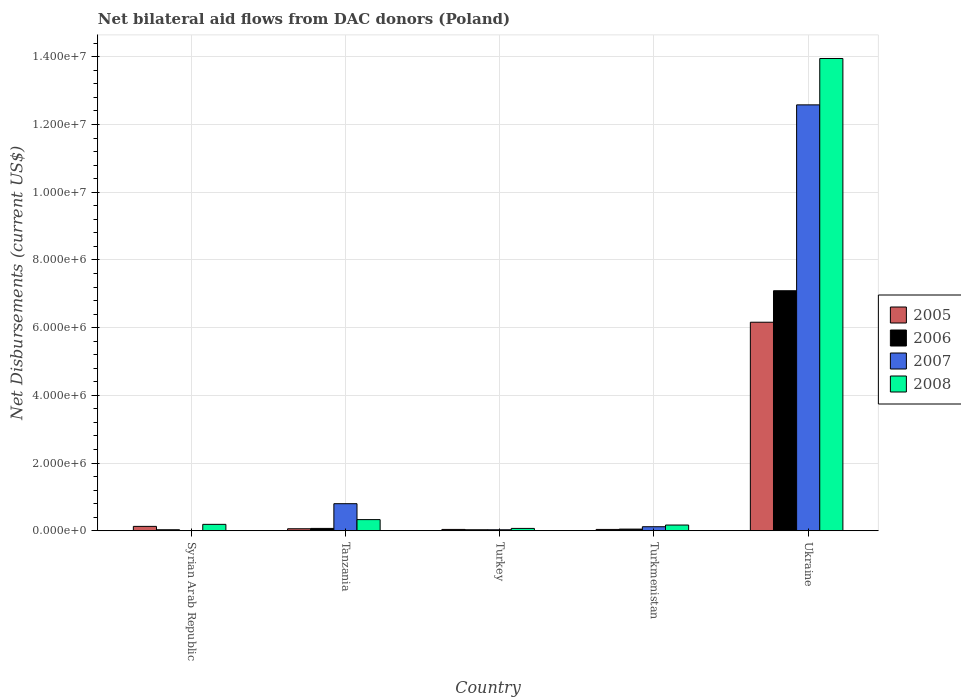How many bars are there on the 2nd tick from the left?
Provide a short and direct response. 4. What is the label of the 2nd group of bars from the left?
Your response must be concise. Tanzania. In how many cases, is the number of bars for a given country not equal to the number of legend labels?
Offer a very short reply. 1. What is the net bilateral aid flows in 2007 in Turkey?
Your response must be concise. 3.00e+04. Across all countries, what is the maximum net bilateral aid flows in 2007?
Provide a succinct answer. 1.26e+07. Across all countries, what is the minimum net bilateral aid flows in 2008?
Offer a very short reply. 7.00e+04. In which country was the net bilateral aid flows in 2006 maximum?
Offer a terse response. Ukraine. What is the total net bilateral aid flows in 2005 in the graph?
Offer a very short reply. 6.43e+06. What is the difference between the net bilateral aid flows in 2007 in Tanzania and the net bilateral aid flows in 2008 in Turkey?
Provide a succinct answer. 7.30e+05. What is the average net bilateral aid flows in 2008 per country?
Your answer should be very brief. 2.94e+06. What is the ratio of the net bilateral aid flows in 2006 in Syrian Arab Republic to that in Turkmenistan?
Your answer should be compact. 0.6. What is the difference between the highest and the second highest net bilateral aid flows in 2008?
Your response must be concise. 1.36e+07. What is the difference between the highest and the lowest net bilateral aid flows in 2005?
Provide a short and direct response. 6.12e+06. How many countries are there in the graph?
Offer a terse response. 5. Are the values on the major ticks of Y-axis written in scientific E-notation?
Your answer should be very brief. Yes. Does the graph contain grids?
Your answer should be compact. Yes. What is the title of the graph?
Keep it short and to the point. Net bilateral aid flows from DAC donors (Poland). Does "2005" appear as one of the legend labels in the graph?
Your answer should be very brief. Yes. What is the label or title of the Y-axis?
Offer a very short reply. Net Disbursements (current US$). What is the Net Disbursements (current US$) of 2005 in Syrian Arab Republic?
Ensure brevity in your answer.  1.30e+05. What is the Net Disbursements (current US$) of 2006 in Syrian Arab Republic?
Offer a terse response. 3.00e+04. What is the Net Disbursements (current US$) in 2007 in Syrian Arab Republic?
Your answer should be compact. 0. What is the Net Disbursements (current US$) of 2008 in Syrian Arab Republic?
Ensure brevity in your answer.  1.90e+05. What is the Net Disbursements (current US$) of 2005 in Tanzania?
Your answer should be compact. 6.00e+04. What is the Net Disbursements (current US$) of 2006 in Tanzania?
Give a very brief answer. 7.00e+04. What is the Net Disbursements (current US$) in 2007 in Tanzania?
Your answer should be very brief. 8.00e+05. What is the Net Disbursements (current US$) of 2008 in Tanzania?
Ensure brevity in your answer.  3.30e+05. What is the Net Disbursements (current US$) of 2005 in Turkey?
Ensure brevity in your answer.  4.00e+04. What is the Net Disbursements (current US$) in 2007 in Turkey?
Provide a succinct answer. 3.00e+04. What is the Net Disbursements (current US$) in 2005 in Ukraine?
Keep it short and to the point. 6.16e+06. What is the Net Disbursements (current US$) of 2006 in Ukraine?
Your answer should be compact. 7.09e+06. What is the Net Disbursements (current US$) of 2007 in Ukraine?
Provide a succinct answer. 1.26e+07. What is the Net Disbursements (current US$) of 2008 in Ukraine?
Ensure brevity in your answer.  1.40e+07. Across all countries, what is the maximum Net Disbursements (current US$) of 2005?
Make the answer very short. 6.16e+06. Across all countries, what is the maximum Net Disbursements (current US$) of 2006?
Provide a succinct answer. 7.09e+06. Across all countries, what is the maximum Net Disbursements (current US$) in 2007?
Ensure brevity in your answer.  1.26e+07. Across all countries, what is the maximum Net Disbursements (current US$) in 2008?
Your response must be concise. 1.40e+07. Across all countries, what is the minimum Net Disbursements (current US$) in 2005?
Offer a terse response. 4.00e+04. Across all countries, what is the minimum Net Disbursements (current US$) of 2006?
Keep it short and to the point. 3.00e+04. Across all countries, what is the minimum Net Disbursements (current US$) of 2008?
Your answer should be compact. 7.00e+04. What is the total Net Disbursements (current US$) in 2005 in the graph?
Your response must be concise. 6.43e+06. What is the total Net Disbursements (current US$) in 2006 in the graph?
Your answer should be compact. 7.27e+06. What is the total Net Disbursements (current US$) in 2007 in the graph?
Keep it short and to the point. 1.35e+07. What is the total Net Disbursements (current US$) of 2008 in the graph?
Offer a terse response. 1.47e+07. What is the difference between the Net Disbursements (current US$) of 2006 in Syrian Arab Republic and that in Tanzania?
Provide a succinct answer. -4.00e+04. What is the difference between the Net Disbursements (current US$) of 2008 in Syrian Arab Republic and that in Tanzania?
Ensure brevity in your answer.  -1.40e+05. What is the difference between the Net Disbursements (current US$) of 2008 in Syrian Arab Republic and that in Turkmenistan?
Your response must be concise. 2.00e+04. What is the difference between the Net Disbursements (current US$) of 2005 in Syrian Arab Republic and that in Ukraine?
Your answer should be very brief. -6.03e+06. What is the difference between the Net Disbursements (current US$) in 2006 in Syrian Arab Republic and that in Ukraine?
Provide a short and direct response. -7.06e+06. What is the difference between the Net Disbursements (current US$) in 2008 in Syrian Arab Republic and that in Ukraine?
Your response must be concise. -1.38e+07. What is the difference between the Net Disbursements (current US$) in 2006 in Tanzania and that in Turkey?
Give a very brief answer. 4.00e+04. What is the difference between the Net Disbursements (current US$) of 2007 in Tanzania and that in Turkey?
Your answer should be compact. 7.70e+05. What is the difference between the Net Disbursements (current US$) in 2008 in Tanzania and that in Turkey?
Make the answer very short. 2.60e+05. What is the difference between the Net Disbursements (current US$) in 2005 in Tanzania and that in Turkmenistan?
Your response must be concise. 2.00e+04. What is the difference between the Net Disbursements (current US$) in 2006 in Tanzania and that in Turkmenistan?
Give a very brief answer. 2.00e+04. What is the difference between the Net Disbursements (current US$) of 2007 in Tanzania and that in Turkmenistan?
Give a very brief answer. 6.80e+05. What is the difference between the Net Disbursements (current US$) of 2008 in Tanzania and that in Turkmenistan?
Give a very brief answer. 1.60e+05. What is the difference between the Net Disbursements (current US$) in 2005 in Tanzania and that in Ukraine?
Give a very brief answer. -6.10e+06. What is the difference between the Net Disbursements (current US$) in 2006 in Tanzania and that in Ukraine?
Offer a very short reply. -7.02e+06. What is the difference between the Net Disbursements (current US$) in 2007 in Tanzania and that in Ukraine?
Offer a terse response. -1.18e+07. What is the difference between the Net Disbursements (current US$) of 2008 in Tanzania and that in Ukraine?
Offer a very short reply. -1.36e+07. What is the difference between the Net Disbursements (current US$) of 2005 in Turkey and that in Ukraine?
Provide a succinct answer. -6.12e+06. What is the difference between the Net Disbursements (current US$) of 2006 in Turkey and that in Ukraine?
Offer a terse response. -7.06e+06. What is the difference between the Net Disbursements (current US$) of 2007 in Turkey and that in Ukraine?
Make the answer very short. -1.26e+07. What is the difference between the Net Disbursements (current US$) in 2008 in Turkey and that in Ukraine?
Make the answer very short. -1.39e+07. What is the difference between the Net Disbursements (current US$) in 2005 in Turkmenistan and that in Ukraine?
Offer a terse response. -6.12e+06. What is the difference between the Net Disbursements (current US$) in 2006 in Turkmenistan and that in Ukraine?
Your answer should be very brief. -7.04e+06. What is the difference between the Net Disbursements (current US$) of 2007 in Turkmenistan and that in Ukraine?
Keep it short and to the point. -1.25e+07. What is the difference between the Net Disbursements (current US$) of 2008 in Turkmenistan and that in Ukraine?
Make the answer very short. -1.38e+07. What is the difference between the Net Disbursements (current US$) of 2005 in Syrian Arab Republic and the Net Disbursements (current US$) of 2006 in Tanzania?
Offer a very short reply. 6.00e+04. What is the difference between the Net Disbursements (current US$) in 2005 in Syrian Arab Republic and the Net Disbursements (current US$) in 2007 in Tanzania?
Provide a short and direct response. -6.70e+05. What is the difference between the Net Disbursements (current US$) in 2006 in Syrian Arab Republic and the Net Disbursements (current US$) in 2007 in Tanzania?
Offer a terse response. -7.70e+05. What is the difference between the Net Disbursements (current US$) in 2006 in Syrian Arab Republic and the Net Disbursements (current US$) in 2008 in Tanzania?
Provide a succinct answer. -3.00e+05. What is the difference between the Net Disbursements (current US$) in 2005 in Syrian Arab Republic and the Net Disbursements (current US$) in 2007 in Turkey?
Offer a terse response. 1.00e+05. What is the difference between the Net Disbursements (current US$) of 2006 in Syrian Arab Republic and the Net Disbursements (current US$) of 2007 in Turkmenistan?
Make the answer very short. -9.00e+04. What is the difference between the Net Disbursements (current US$) in 2006 in Syrian Arab Republic and the Net Disbursements (current US$) in 2008 in Turkmenistan?
Provide a succinct answer. -1.40e+05. What is the difference between the Net Disbursements (current US$) of 2005 in Syrian Arab Republic and the Net Disbursements (current US$) of 2006 in Ukraine?
Give a very brief answer. -6.96e+06. What is the difference between the Net Disbursements (current US$) in 2005 in Syrian Arab Republic and the Net Disbursements (current US$) in 2007 in Ukraine?
Your response must be concise. -1.24e+07. What is the difference between the Net Disbursements (current US$) of 2005 in Syrian Arab Republic and the Net Disbursements (current US$) of 2008 in Ukraine?
Provide a succinct answer. -1.38e+07. What is the difference between the Net Disbursements (current US$) in 2006 in Syrian Arab Republic and the Net Disbursements (current US$) in 2007 in Ukraine?
Your response must be concise. -1.26e+07. What is the difference between the Net Disbursements (current US$) in 2006 in Syrian Arab Republic and the Net Disbursements (current US$) in 2008 in Ukraine?
Your answer should be very brief. -1.39e+07. What is the difference between the Net Disbursements (current US$) of 2005 in Tanzania and the Net Disbursements (current US$) of 2007 in Turkey?
Make the answer very short. 3.00e+04. What is the difference between the Net Disbursements (current US$) in 2005 in Tanzania and the Net Disbursements (current US$) in 2008 in Turkey?
Keep it short and to the point. -10000. What is the difference between the Net Disbursements (current US$) of 2006 in Tanzania and the Net Disbursements (current US$) of 2007 in Turkey?
Keep it short and to the point. 4.00e+04. What is the difference between the Net Disbursements (current US$) in 2007 in Tanzania and the Net Disbursements (current US$) in 2008 in Turkey?
Keep it short and to the point. 7.30e+05. What is the difference between the Net Disbursements (current US$) of 2005 in Tanzania and the Net Disbursements (current US$) of 2006 in Turkmenistan?
Ensure brevity in your answer.  10000. What is the difference between the Net Disbursements (current US$) in 2005 in Tanzania and the Net Disbursements (current US$) in 2008 in Turkmenistan?
Provide a short and direct response. -1.10e+05. What is the difference between the Net Disbursements (current US$) in 2006 in Tanzania and the Net Disbursements (current US$) in 2007 in Turkmenistan?
Keep it short and to the point. -5.00e+04. What is the difference between the Net Disbursements (current US$) in 2006 in Tanzania and the Net Disbursements (current US$) in 2008 in Turkmenistan?
Your response must be concise. -1.00e+05. What is the difference between the Net Disbursements (current US$) of 2007 in Tanzania and the Net Disbursements (current US$) of 2008 in Turkmenistan?
Give a very brief answer. 6.30e+05. What is the difference between the Net Disbursements (current US$) in 2005 in Tanzania and the Net Disbursements (current US$) in 2006 in Ukraine?
Provide a succinct answer. -7.03e+06. What is the difference between the Net Disbursements (current US$) in 2005 in Tanzania and the Net Disbursements (current US$) in 2007 in Ukraine?
Your answer should be very brief. -1.25e+07. What is the difference between the Net Disbursements (current US$) in 2005 in Tanzania and the Net Disbursements (current US$) in 2008 in Ukraine?
Keep it short and to the point. -1.39e+07. What is the difference between the Net Disbursements (current US$) of 2006 in Tanzania and the Net Disbursements (current US$) of 2007 in Ukraine?
Give a very brief answer. -1.25e+07. What is the difference between the Net Disbursements (current US$) of 2006 in Tanzania and the Net Disbursements (current US$) of 2008 in Ukraine?
Give a very brief answer. -1.39e+07. What is the difference between the Net Disbursements (current US$) of 2007 in Tanzania and the Net Disbursements (current US$) of 2008 in Ukraine?
Ensure brevity in your answer.  -1.32e+07. What is the difference between the Net Disbursements (current US$) of 2005 in Turkey and the Net Disbursements (current US$) of 2007 in Turkmenistan?
Ensure brevity in your answer.  -8.00e+04. What is the difference between the Net Disbursements (current US$) of 2005 in Turkey and the Net Disbursements (current US$) of 2008 in Turkmenistan?
Keep it short and to the point. -1.30e+05. What is the difference between the Net Disbursements (current US$) of 2005 in Turkey and the Net Disbursements (current US$) of 2006 in Ukraine?
Your answer should be compact. -7.05e+06. What is the difference between the Net Disbursements (current US$) of 2005 in Turkey and the Net Disbursements (current US$) of 2007 in Ukraine?
Keep it short and to the point. -1.25e+07. What is the difference between the Net Disbursements (current US$) of 2005 in Turkey and the Net Disbursements (current US$) of 2008 in Ukraine?
Your answer should be very brief. -1.39e+07. What is the difference between the Net Disbursements (current US$) in 2006 in Turkey and the Net Disbursements (current US$) in 2007 in Ukraine?
Provide a short and direct response. -1.26e+07. What is the difference between the Net Disbursements (current US$) of 2006 in Turkey and the Net Disbursements (current US$) of 2008 in Ukraine?
Provide a succinct answer. -1.39e+07. What is the difference between the Net Disbursements (current US$) in 2007 in Turkey and the Net Disbursements (current US$) in 2008 in Ukraine?
Your response must be concise. -1.39e+07. What is the difference between the Net Disbursements (current US$) in 2005 in Turkmenistan and the Net Disbursements (current US$) in 2006 in Ukraine?
Your response must be concise. -7.05e+06. What is the difference between the Net Disbursements (current US$) in 2005 in Turkmenistan and the Net Disbursements (current US$) in 2007 in Ukraine?
Make the answer very short. -1.25e+07. What is the difference between the Net Disbursements (current US$) in 2005 in Turkmenistan and the Net Disbursements (current US$) in 2008 in Ukraine?
Your response must be concise. -1.39e+07. What is the difference between the Net Disbursements (current US$) of 2006 in Turkmenistan and the Net Disbursements (current US$) of 2007 in Ukraine?
Provide a short and direct response. -1.25e+07. What is the difference between the Net Disbursements (current US$) of 2006 in Turkmenistan and the Net Disbursements (current US$) of 2008 in Ukraine?
Ensure brevity in your answer.  -1.39e+07. What is the difference between the Net Disbursements (current US$) of 2007 in Turkmenistan and the Net Disbursements (current US$) of 2008 in Ukraine?
Provide a short and direct response. -1.38e+07. What is the average Net Disbursements (current US$) in 2005 per country?
Ensure brevity in your answer.  1.29e+06. What is the average Net Disbursements (current US$) in 2006 per country?
Keep it short and to the point. 1.45e+06. What is the average Net Disbursements (current US$) of 2007 per country?
Provide a succinct answer. 2.71e+06. What is the average Net Disbursements (current US$) in 2008 per country?
Offer a terse response. 2.94e+06. What is the difference between the Net Disbursements (current US$) of 2005 and Net Disbursements (current US$) of 2006 in Syrian Arab Republic?
Your answer should be very brief. 1.00e+05. What is the difference between the Net Disbursements (current US$) of 2005 and Net Disbursements (current US$) of 2008 in Syrian Arab Republic?
Keep it short and to the point. -6.00e+04. What is the difference between the Net Disbursements (current US$) in 2005 and Net Disbursements (current US$) in 2006 in Tanzania?
Provide a short and direct response. -10000. What is the difference between the Net Disbursements (current US$) of 2005 and Net Disbursements (current US$) of 2007 in Tanzania?
Your answer should be very brief. -7.40e+05. What is the difference between the Net Disbursements (current US$) of 2006 and Net Disbursements (current US$) of 2007 in Tanzania?
Provide a succinct answer. -7.30e+05. What is the difference between the Net Disbursements (current US$) in 2006 and Net Disbursements (current US$) in 2008 in Tanzania?
Make the answer very short. -2.60e+05. What is the difference between the Net Disbursements (current US$) in 2007 and Net Disbursements (current US$) in 2008 in Tanzania?
Make the answer very short. 4.70e+05. What is the difference between the Net Disbursements (current US$) in 2005 and Net Disbursements (current US$) in 2007 in Turkey?
Provide a short and direct response. 10000. What is the difference between the Net Disbursements (current US$) of 2006 and Net Disbursements (current US$) of 2007 in Turkey?
Offer a terse response. 0. What is the difference between the Net Disbursements (current US$) in 2007 and Net Disbursements (current US$) in 2008 in Turkey?
Give a very brief answer. -4.00e+04. What is the difference between the Net Disbursements (current US$) in 2005 and Net Disbursements (current US$) in 2008 in Turkmenistan?
Offer a terse response. -1.30e+05. What is the difference between the Net Disbursements (current US$) in 2006 and Net Disbursements (current US$) in 2007 in Turkmenistan?
Your answer should be compact. -7.00e+04. What is the difference between the Net Disbursements (current US$) of 2005 and Net Disbursements (current US$) of 2006 in Ukraine?
Give a very brief answer. -9.30e+05. What is the difference between the Net Disbursements (current US$) of 2005 and Net Disbursements (current US$) of 2007 in Ukraine?
Your answer should be compact. -6.42e+06. What is the difference between the Net Disbursements (current US$) in 2005 and Net Disbursements (current US$) in 2008 in Ukraine?
Your response must be concise. -7.79e+06. What is the difference between the Net Disbursements (current US$) in 2006 and Net Disbursements (current US$) in 2007 in Ukraine?
Provide a succinct answer. -5.49e+06. What is the difference between the Net Disbursements (current US$) in 2006 and Net Disbursements (current US$) in 2008 in Ukraine?
Offer a terse response. -6.86e+06. What is the difference between the Net Disbursements (current US$) of 2007 and Net Disbursements (current US$) of 2008 in Ukraine?
Offer a very short reply. -1.37e+06. What is the ratio of the Net Disbursements (current US$) of 2005 in Syrian Arab Republic to that in Tanzania?
Ensure brevity in your answer.  2.17. What is the ratio of the Net Disbursements (current US$) of 2006 in Syrian Arab Republic to that in Tanzania?
Provide a succinct answer. 0.43. What is the ratio of the Net Disbursements (current US$) of 2008 in Syrian Arab Republic to that in Tanzania?
Offer a very short reply. 0.58. What is the ratio of the Net Disbursements (current US$) of 2006 in Syrian Arab Republic to that in Turkey?
Make the answer very short. 1. What is the ratio of the Net Disbursements (current US$) of 2008 in Syrian Arab Republic to that in Turkey?
Your answer should be compact. 2.71. What is the ratio of the Net Disbursements (current US$) in 2005 in Syrian Arab Republic to that in Turkmenistan?
Keep it short and to the point. 3.25. What is the ratio of the Net Disbursements (current US$) in 2006 in Syrian Arab Republic to that in Turkmenistan?
Keep it short and to the point. 0.6. What is the ratio of the Net Disbursements (current US$) in 2008 in Syrian Arab Republic to that in Turkmenistan?
Ensure brevity in your answer.  1.12. What is the ratio of the Net Disbursements (current US$) in 2005 in Syrian Arab Republic to that in Ukraine?
Provide a short and direct response. 0.02. What is the ratio of the Net Disbursements (current US$) in 2006 in Syrian Arab Republic to that in Ukraine?
Give a very brief answer. 0. What is the ratio of the Net Disbursements (current US$) in 2008 in Syrian Arab Republic to that in Ukraine?
Your answer should be very brief. 0.01. What is the ratio of the Net Disbursements (current US$) in 2005 in Tanzania to that in Turkey?
Your answer should be very brief. 1.5. What is the ratio of the Net Disbursements (current US$) of 2006 in Tanzania to that in Turkey?
Your answer should be compact. 2.33. What is the ratio of the Net Disbursements (current US$) in 2007 in Tanzania to that in Turkey?
Ensure brevity in your answer.  26.67. What is the ratio of the Net Disbursements (current US$) in 2008 in Tanzania to that in Turkey?
Your answer should be compact. 4.71. What is the ratio of the Net Disbursements (current US$) in 2006 in Tanzania to that in Turkmenistan?
Give a very brief answer. 1.4. What is the ratio of the Net Disbursements (current US$) in 2008 in Tanzania to that in Turkmenistan?
Offer a terse response. 1.94. What is the ratio of the Net Disbursements (current US$) in 2005 in Tanzania to that in Ukraine?
Keep it short and to the point. 0.01. What is the ratio of the Net Disbursements (current US$) of 2006 in Tanzania to that in Ukraine?
Offer a terse response. 0.01. What is the ratio of the Net Disbursements (current US$) of 2007 in Tanzania to that in Ukraine?
Keep it short and to the point. 0.06. What is the ratio of the Net Disbursements (current US$) in 2008 in Tanzania to that in Ukraine?
Ensure brevity in your answer.  0.02. What is the ratio of the Net Disbursements (current US$) of 2005 in Turkey to that in Turkmenistan?
Your answer should be compact. 1. What is the ratio of the Net Disbursements (current US$) in 2006 in Turkey to that in Turkmenistan?
Make the answer very short. 0.6. What is the ratio of the Net Disbursements (current US$) of 2007 in Turkey to that in Turkmenistan?
Provide a succinct answer. 0.25. What is the ratio of the Net Disbursements (current US$) in 2008 in Turkey to that in Turkmenistan?
Provide a short and direct response. 0.41. What is the ratio of the Net Disbursements (current US$) of 2005 in Turkey to that in Ukraine?
Offer a terse response. 0.01. What is the ratio of the Net Disbursements (current US$) of 2006 in Turkey to that in Ukraine?
Offer a terse response. 0. What is the ratio of the Net Disbursements (current US$) in 2007 in Turkey to that in Ukraine?
Provide a short and direct response. 0. What is the ratio of the Net Disbursements (current US$) in 2008 in Turkey to that in Ukraine?
Provide a succinct answer. 0.01. What is the ratio of the Net Disbursements (current US$) of 2005 in Turkmenistan to that in Ukraine?
Provide a succinct answer. 0.01. What is the ratio of the Net Disbursements (current US$) in 2006 in Turkmenistan to that in Ukraine?
Make the answer very short. 0.01. What is the ratio of the Net Disbursements (current US$) of 2007 in Turkmenistan to that in Ukraine?
Provide a succinct answer. 0.01. What is the ratio of the Net Disbursements (current US$) of 2008 in Turkmenistan to that in Ukraine?
Keep it short and to the point. 0.01. What is the difference between the highest and the second highest Net Disbursements (current US$) in 2005?
Your response must be concise. 6.03e+06. What is the difference between the highest and the second highest Net Disbursements (current US$) in 2006?
Provide a succinct answer. 7.02e+06. What is the difference between the highest and the second highest Net Disbursements (current US$) in 2007?
Provide a succinct answer. 1.18e+07. What is the difference between the highest and the second highest Net Disbursements (current US$) in 2008?
Provide a succinct answer. 1.36e+07. What is the difference between the highest and the lowest Net Disbursements (current US$) of 2005?
Offer a very short reply. 6.12e+06. What is the difference between the highest and the lowest Net Disbursements (current US$) in 2006?
Keep it short and to the point. 7.06e+06. What is the difference between the highest and the lowest Net Disbursements (current US$) of 2007?
Provide a succinct answer. 1.26e+07. What is the difference between the highest and the lowest Net Disbursements (current US$) in 2008?
Your answer should be compact. 1.39e+07. 